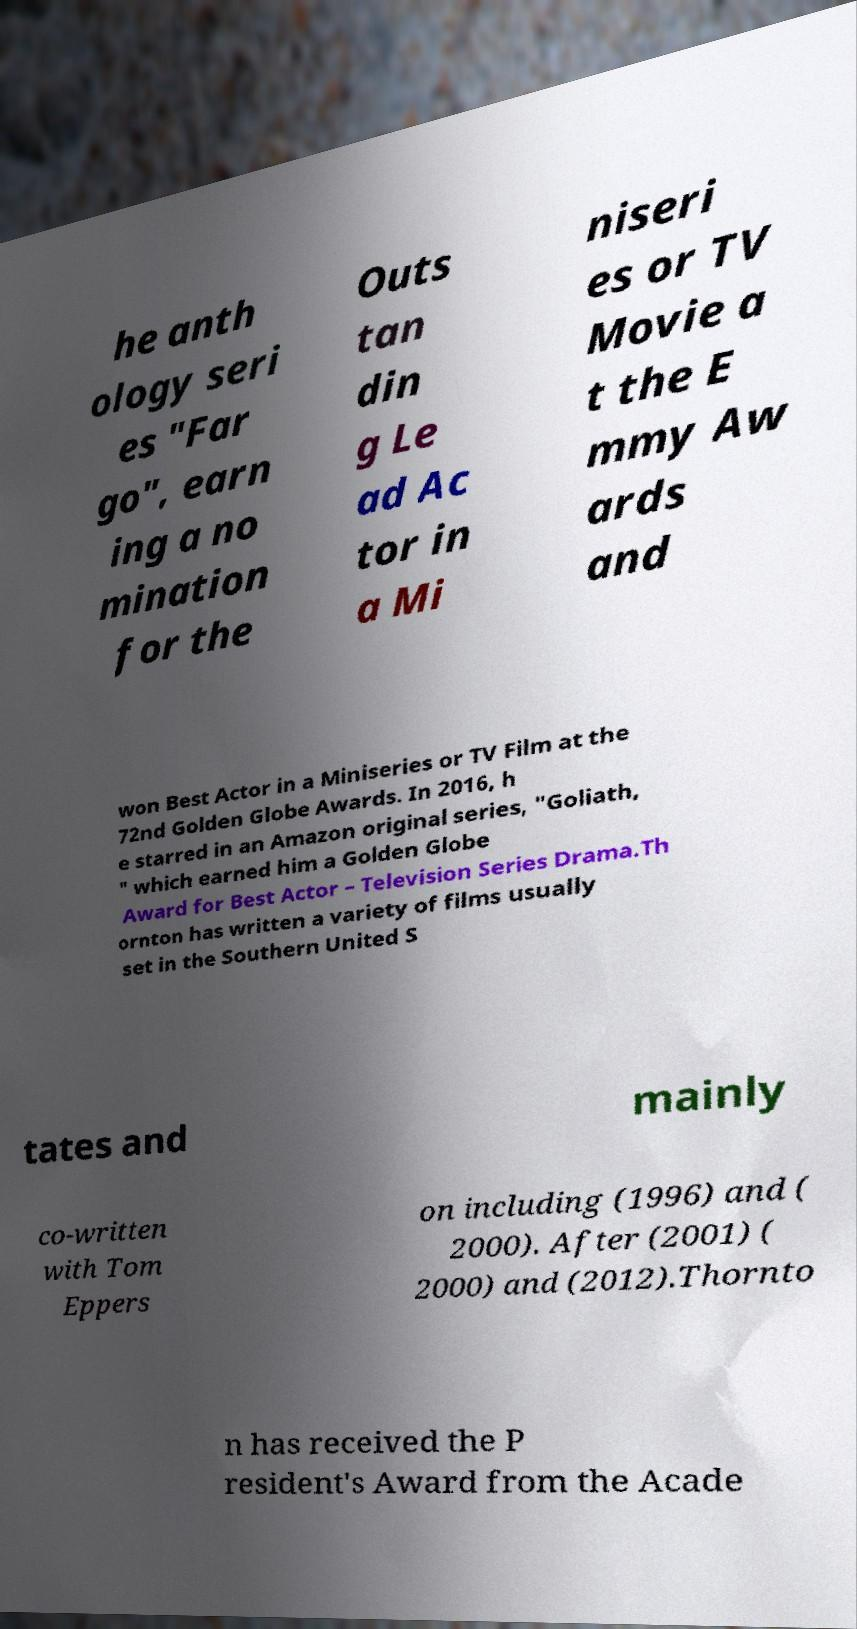Could you assist in decoding the text presented in this image and type it out clearly? he anth ology seri es "Far go", earn ing a no mination for the Outs tan din g Le ad Ac tor in a Mi niseri es or TV Movie a t the E mmy Aw ards and won Best Actor in a Miniseries or TV Film at the 72nd Golden Globe Awards. In 2016, h e starred in an Amazon original series, "Goliath, " which earned him a Golden Globe Award for Best Actor – Television Series Drama.Th ornton has written a variety of films usually set in the Southern United S tates and mainly co-written with Tom Eppers on including (1996) and ( 2000). After (2001) ( 2000) and (2012).Thornto n has received the P resident's Award from the Acade 